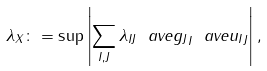Convert formula to latex. <formula><loc_0><loc_0><loc_500><loc_500>\| \lambda \| _ { X } \colon = \sup \left | \sum _ { I , J } \lambda _ { I J } \ a v e { g _ { J } } _ { I } \ a v e { u _ { I } } _ { J } \right | ,</formula> 